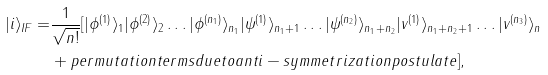Convert formula to latex. <formula><loc_0><loc_0><loc_500><loc_500>| i \rangle _ { I F } = & \frac { 1 } { \sqrt { n ! } } [ | \phi ^ { ( 1 ) } \rangle _ { 1 } | \phi ^ { ( 2 ) } \rangle _ { 2 } \dots | \phi ^ { ( n _ { 1 } ) } \rangle _ { n _ { 1 } } | \psi ^ { ( 1 ) } \rangle _ { n _ { 1 } + 1 } \dots | \psi ^ { ( n _ { 2 } ) } \rangle _ { n _ { 1 } + n _ { 2 } } | v ^ { ( 1 ) } \rangle _ { n _ { 1 } + n _ { 2 } + 1 } \dots | v ^ { ( n _ { 3 } ) } \rangle _ { n } \\ & + p e r m u t a t i o n t e r m s d u e t o a n t i - s y m m e t r i z a t i o n p o s t u l a t e ] ,</formula> 